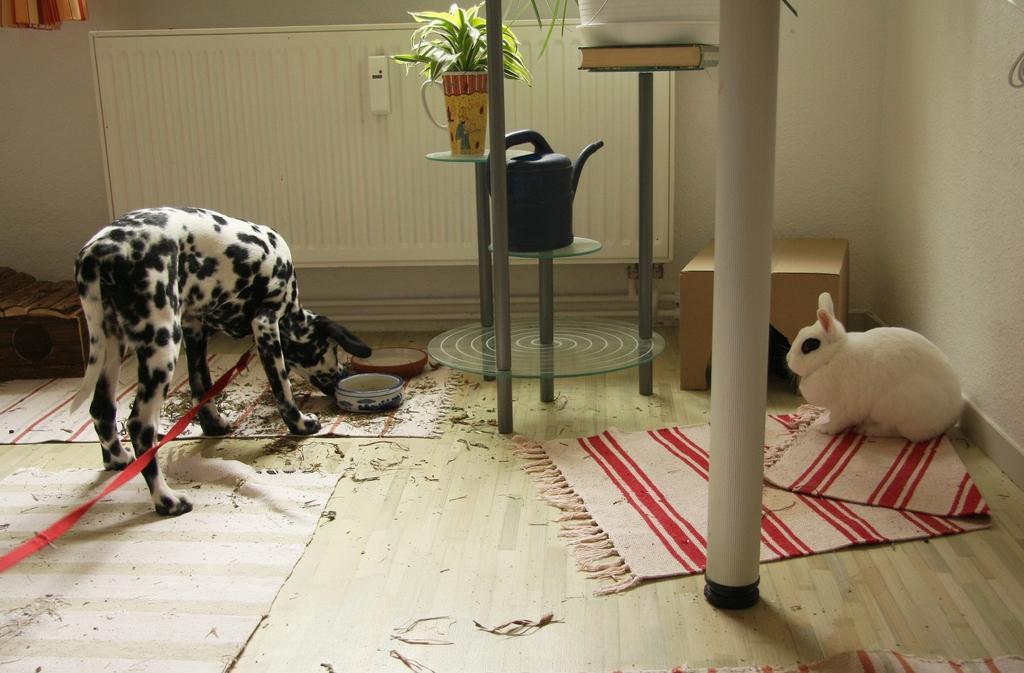How would you summarize this image in a sentence or two? This image is clicked in a room. This room has carpets on the floor, there is a rabbit on right side and the dog on left side. Dog is eating something in the bowl and there is water sprinkler in the middle ,there is a flower pot,there is a curtain on the top left corner ,there are books on the table in the middle of the image, there is a box on the right side. 